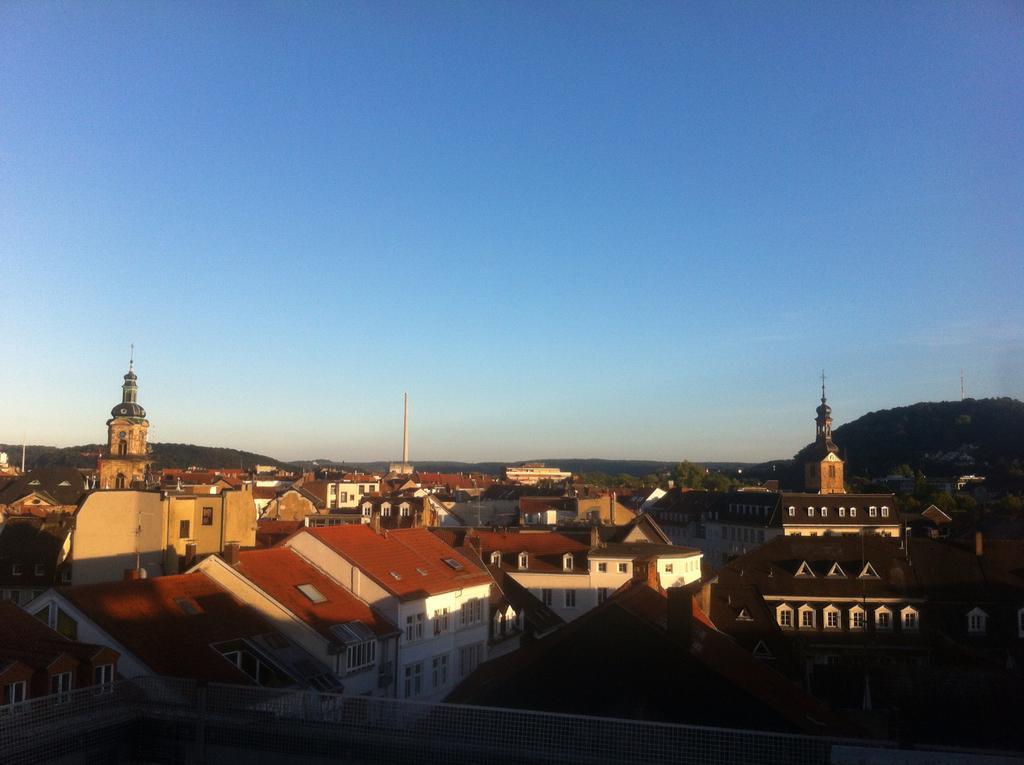Can you describe this image briefly? At the bottom of the image, there are so many buildings and houses, towers, trees, windows and walls. Background we can see hills and clear sky. 